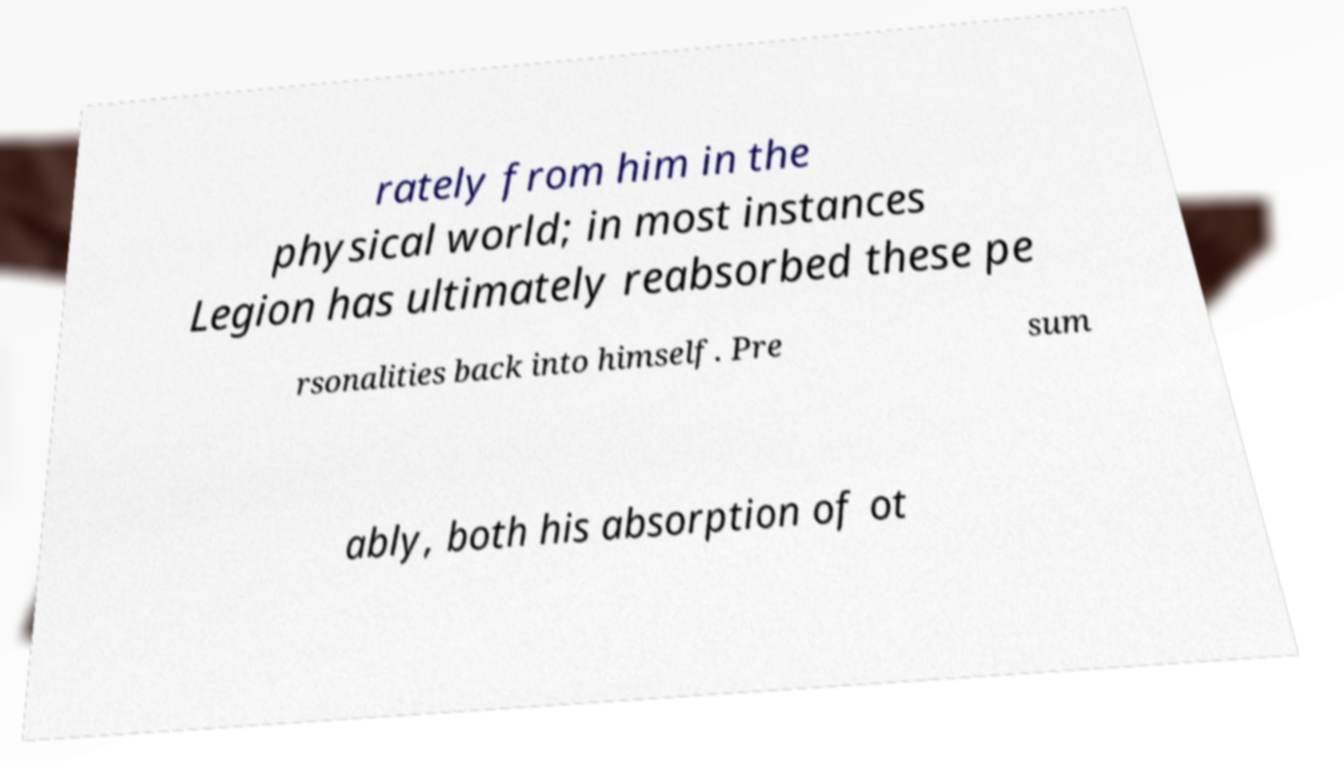Please identify and transcribe the text found in this image. rately from him in the physical world; in most instances Legion has ultimately reabsorbed these pe rsonalities back into himself. Pre sum ably, both his absorption of ot 